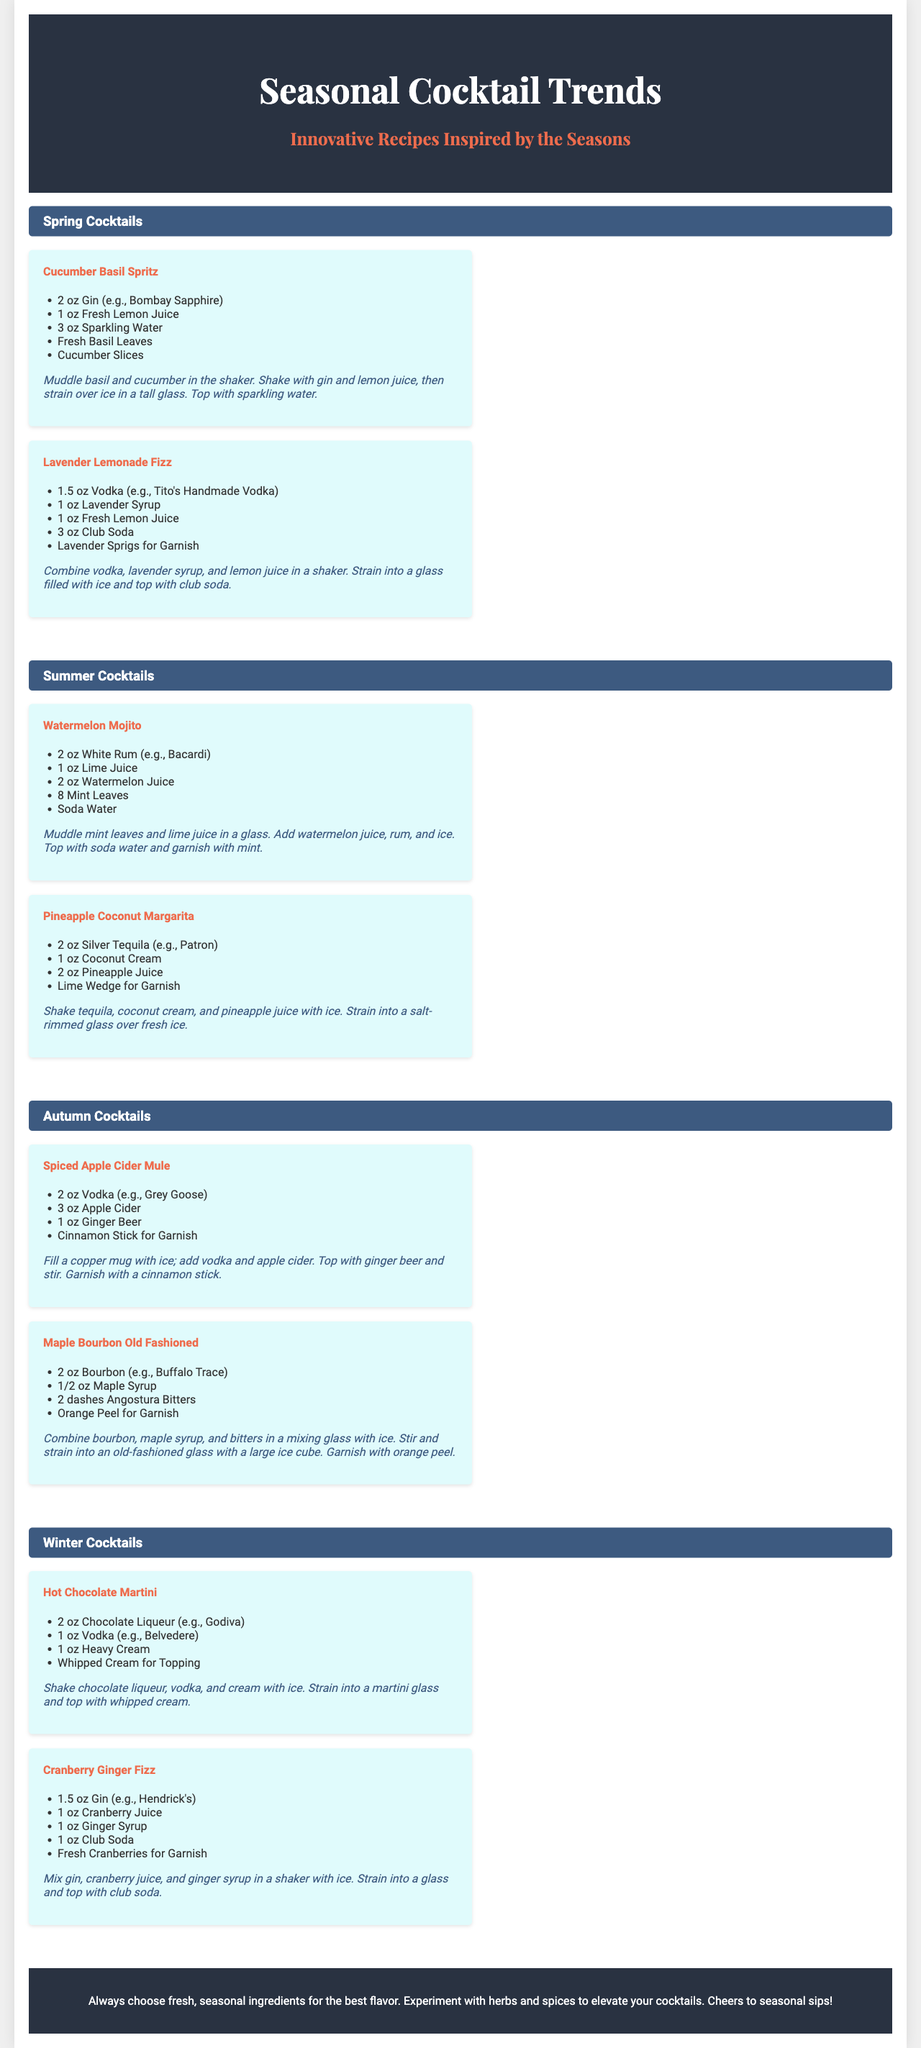What is the title of the brochure? The title of the brochure is displayed prominently at the top of the document.
Answer: Seasonal Cocktail Trends What are the two main mix ingredients in the Cucumber Basil Spritz? The ingredients for the Cucumber Basil Spritz are listed under the cocktail name.
Answer: Gin and Fresh Lemon Juice How many cocktails are listed under Summer Cocktails? The number of cocktails for each season is indicated in the corresponding sections.
Answer: 2 What type of glass is used for the Hot Chocolate Martini? The specific glass type is mentioned in the preparation steps for the cocktail.
Answer: Martini glass What is the main garnish for the Maple Bourbon Old Fashioned? The garnish is specified in the list of ingredients for each cocktail.
Answer: Orange Peel Which spirit is used in the Pineapple Coconut Margarita? The spirit type is mentioned in the ingredient list for the cocktail.
Answer: Silver Tequila What season features the Lavender Lemonade Fizz? The season for each cocktail is noted in its corresponding section header.
Answer: Spring How does the brochure suggest enhancing the flavor of cocktails? The footer of the brochure provides a tip about cocktail preparation.
Answer: Use fresh, seasonal ingredients 